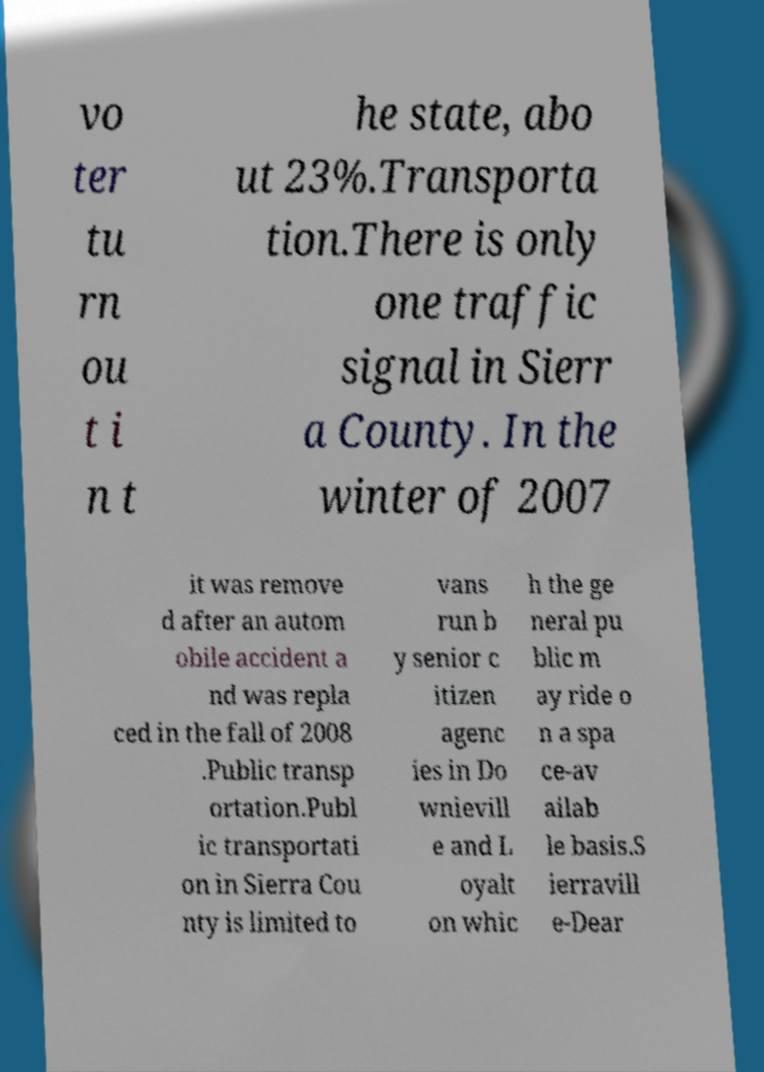What messages or text are displayed in this image? I need them in a readable, typed format. vo ter tu rn ou t i n t he state, abo ut 23%.Transporta tion.There is only one traffic signal in Sierr a County. In the winter of 2007 it was remove d after an autom obile accident a nd was repla ced in the fall of 2008 .Public transp ortation.Publ ic transportati on in Sierra Cou nty is limited to vans run b y senior c itizen agenc ies in Do wnievill e and L oyalt on whic h the ge neral pu blic m ay ride o n a spa ce-av ailab le basis.S ierravill e-Dear 